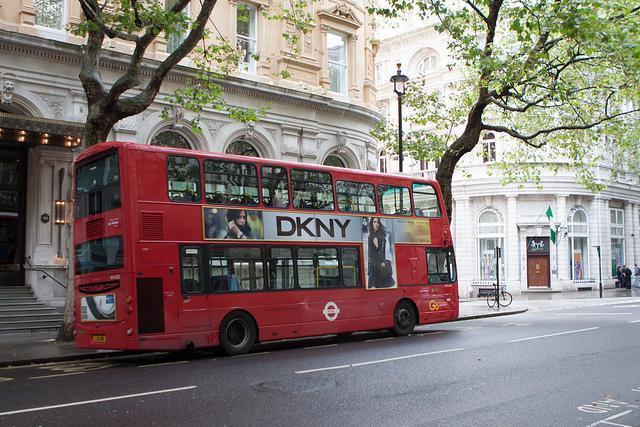What state is the company from whose logo appears on the bus?
Pick the right solution, then justify: 'Answer: answer
Rationale: rationale.'
Options: New york, missouri, oklahoma, michigan. Answer: new york.
Rationale: New york is the center of fashion.  dkny is a company where ny stands for new york. 